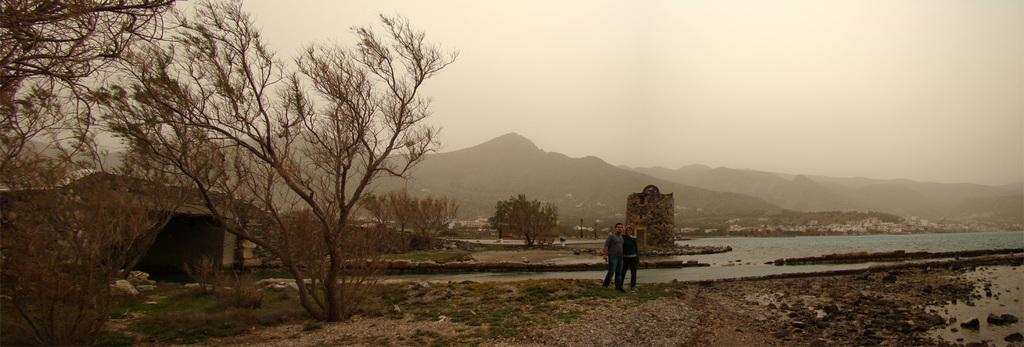How many people are in the image? There are two persons in the image. What is the ground like in the image? The ground is visible in the image, and it appears to have grass. What type of vegetation can be seen in the image? There are plants, trees, and grass in the image. What type of structure is present in the image? There is a bridge in the image. What type of man-made structures can be seen in the image? There are buildings in the image. What natural feature is visible in the image? There are mountains in the image. What part of the natural environment is visible in the image? The sky is visible in the image. What type of wound can be seen on the person's arm in the image? There is no wound visible on any person's arm in the image. What type of punishment is being administered to the person in the image? There is no punishment being administered to any person in the image. 